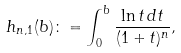<formula> <loc_0><loc_0><loc_500><loc_500>h _ { n , 1 } ( b ) \colon = \int _ { 0 } ^ { b } \frac { \ln t \, d t } { ( 1 + t ) ^ { n } } ,</formula> 